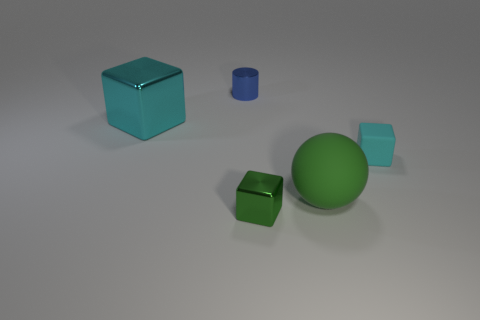The matte thing that is the same color as the small metal cube is what shape?
Provide a short and direct response. Sphere. What is the color of the big shiny object?
Make the answer very short. Cyan. There is a metallic thing that is left of the small blue thing; does it have the same shape as the large green object?
Provide a short and direct response. No. What number of objects are things on the right side of the big metallic cube or tiny gray balls?
Provide a short and direct response. 4. Are there any blue metal objects of the same shape as the small cyan object?
Provide a short and direct response. No. The rubber thing that is the same size as the green block is what shape?
Your answer should be very brief. Cube. What is the shape of the matte thing left of the cyan block in front of the cyan thing to the left of the big matte object?
Your response must be concise. Sphere. There is a large cyan object; is its shape the same as the green thing behind the green metal thing?
Keep it short and to the point. No. What number of small things are red rubber balls or blue things?
Your answer should be very brief. 1. Is there another thing that has the same size as the green matte object?
Your answer should be compact. Yes. 